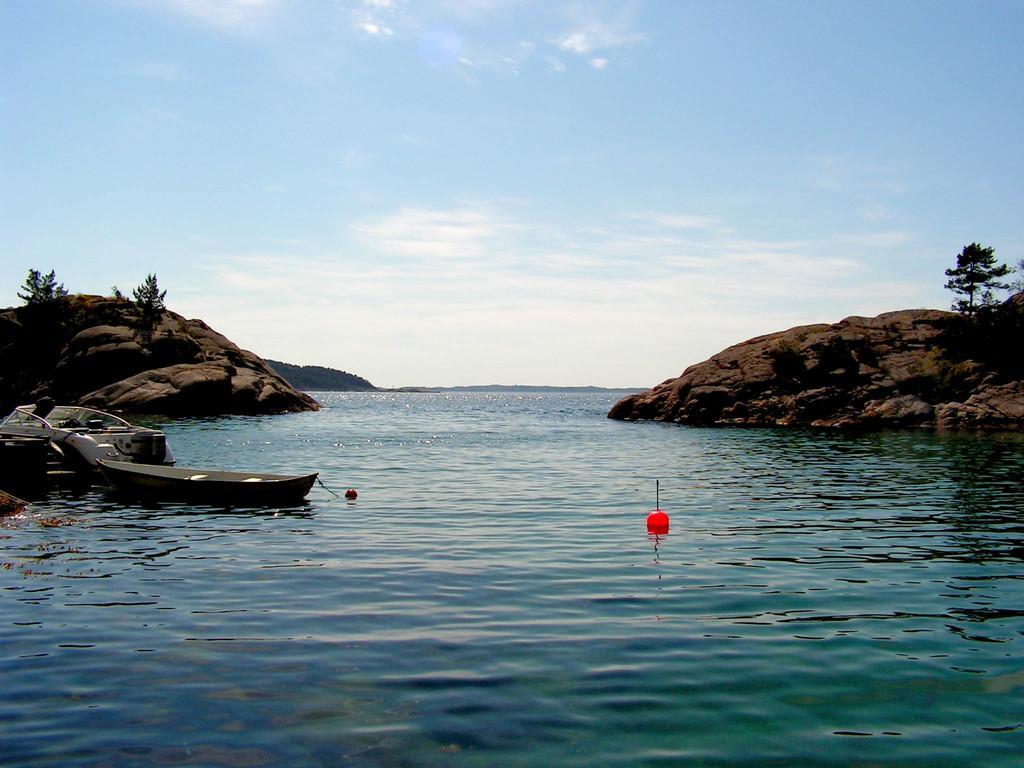Could you give a brief overview of what you see in this image? In this image there is a ship, boat and an object in the red color are on the river. On the either side of the river there are mountains and trees on top of it. In the background there is the sky. 